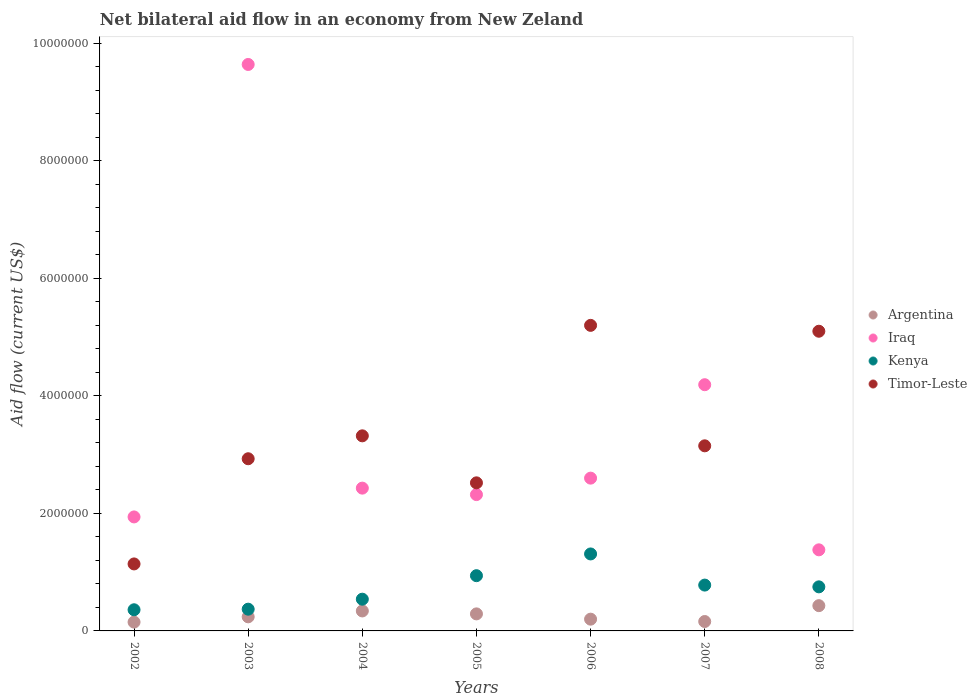What is the net bilateral aid flow in Timor-Leste in 2007?
Provide a succinct answer. 3.15e+06. Across all years, what is the minimum net bilateral aid flow in Iraq?
Offer a very short reply. 1.38e+06. In which year was the net bilateral aid flow in Kenya maximum?
Your answer should be compact. 2006. What is the total net bilateral aid flow in Iraq in the graph?
Provide a succinct answer. 2.45e+07. What is the average net bilateral aid flow in Kenya per year?
Your answer should be very brief. 7.21e+05. In the year 2004, what is the difference between the net bilateral aid flow in Iraq and net bilateral aid flow in Kenya?
Your answer should be very brief. 1.89e+06. In how many years, is the net bilateral aid flow in Argentina greater than 9600000 US$?
Offer a terse response. 0. What is the ratio of the net bilateral aid flow in Timor-Leste in 2004 to that in 2006?
Your answer should be very brief. 0.64. Is the net bilateral aid flow in Kenya in 2003 less than that in 2004?
Give a very brief answer. Yes. Is the difference between the net bilateral aid flow in Iraq in 2002 and 2008 greater than the difference between the net bilateral aid flow in Kenya in 2002 and 2008?
Your response must be concise. Yes. What is the difference between the highest and the second highest net bilateral aid flow in Timor-Leste?
Provide a short and direct response. 1.00e+05. In how many years, is the net bilateral aid flow in Timor-Leste greater than the average net bilateral aid flow in Timor-Leste taken over all years?
Your response must be concise. 2. Is the sum of the net bilateral aid flow in Iraq in 2003 and 2004 greater than the maximum net bilateral aid flow in Timor-Leste across all years?
Offer a very short reply. Yes. Is it the case that in every year, the sum of the net bilateral aid flow in Timor-Leste and net bilateral aid flow in Iraq  is greater than the sum of net bilateral aid flow in Kenya and net bilateral aid flow in Argentina?
Make the answer very short. Yes. Is it the case that in every year, the sum of the net bilateral aid flow in Iraq and net bilateral aid flow in Kenya  is greater than the net bilateral aid flow in Timor-Leste?
Make the answer very short. No. Does the net bilateral aid flow in Argentina monotonically increase over the years?
Your answer should be very brief. No. How many years are there in the graph?
Make the answer very short. 7. What is the difference between two consecutive major ticks on the Y-axis?
Your answer should be compact. 2.00e+06. Does the graph contain any zero values?
Your response must be concise. No. How are the legend labels stacked?
Ensure brevity in your answer.  Vertical. What is the title of the graph?
Ensure brevity in your answer.  Net bilateral aid flow in an economy from New Zeland. Does "Suriname" appear as one of the legend labels in the graph?
Provide a short and direct response. No. What is the Aid flow (current US$) of Argentina in 2002?
Provide a short and direct response. 1.50e+05. What is the Aid flow (current US$) in Iraq in 2002?
Make the answer very short. 1.94e+06. What is the Aid flow (current US$) in Timor-Leste in 2002?
Your response must be concise. 1.14e+06. What is the Aid flow (current US$) in Iraq in 2003?
Offer a very short reply. 9.64e+06. What is the Aid flow (current US$) in Timor-Leste in 2003?
Offer a terse response. 2.93e+06. What is the Aid flow (current US$) of Iraq in 2004?
Provide a succinct answer. 2.43e+06. What is the Aid flow (current US$) of Kenya in 2004?
Offer a very short reply. 5.40e+05. What is the Aid flow (current US$) of Timor-Leste in 2004?
Make the answer very short. 3.32e+06. What is the Aid flow (current US$) of Iraq in 2005?
Offer a very short reply. 2.32e+06. What is the Aid flow (current US$) of Kenya in 2005?
Provide a succinct answer. 9.40e+05. What is the Aid flow (current US$) in Timor-Leste in 2005?
Make the answer very short. 2.52e+06. What is the Aid flow (current US$) of Iraq in 2006?
Provide a short and direct response. 2.60e+06. What is the Aid flow (current US$) in Kenya in 2006?
Offer a very short reply. 1.31e+06. What is the Aid flow (current US$) in Timor-Leste in 2006?
Ensure brevity in your answer.  5.20e+06. What is the Aid flow (current US$) in Argentina in 2007?
Keep it short and to the point. 1.60e+05. What is the Aid flow (current US$) of Iraq in 2007?
Your answer should be very brief. 4.19e+06. What is the Aid flow (current US$) in Kenya in 2007?
Provide a short and direct response. 7.80e+05. What is the Aid flow (current US$) of Timor-Leste in 2007?
Offer a very short reply. 3.15e+06. What is the Aid flow (current US$) in Argentina in 2008?
Your answer should be compact. 4.30e+05. What is the Aid flow (current US$) of Iraq in 2008?
Make the answer very short. 1.38e+06. What is the Aid flow (current US$) of Kenya in 2008?
Make the answer very short. 7.50e+05. What is the Aid flow (current US$) in Timor-Leste in 2008?
Give a very brief answer. 5.10e+06. Across all years, what is the maximum Aid flow (current US$) of Argentina?
Offer a terse response. 4.30e+05. Across all years, what is the maximum Aid flow (current US$) in Iraq?
Offer a very short reply. 9.64e+06. Across all years, what is the maximum Aid flow (current US$) in Kenya?
Provide a succinct answer. 1.31e+06. Across all years, what is the maximum Aid flow (current US$) in Timor-Leste?
Offer a terse response. 5.20e+06. Across all years, what is the minimum Aid flow (current US$) in Iraq?
Give a very brief answer. 1.38e+06. Across all years, what is the minimum Aid flow (current US$) of Kenya?
Offer a terse response. 3.60e+05. Across all years, what is the minimum Aid flow (current US$) of Timor-Leste?
Your answer should be compact. 1.14e+06. What is the total Aid flow (current US$) in Argentina in the graph?
Provide a short and direct response. 1.81e+06. What is the total Aid flow (current US$) of Iraq in the graph?
Ensure brevity in your answer.  2.45e+07. What is the total Aid flow (current US$) in Kenya in the graph?
Make the answer very short. 5.05e+06. What is the total Aid flow (current US$) of Timor-Leste in the graph?
Your response must be concise. 2.34e+07. What is the difference between the Aid flow (current US$) of Iraq in 2002 and that in 2003?
Provide a short and direct response. -7.70e+06. What is the difference between the Aid flow (current US$) of Kenya in 2002 and that in 2003?
Give a very brief answer. -10000. What is the difference between the Aid flow (current US$) in Timor-Leste in 2002 and that in 2003?
Offer a very short reply. -1.79e+06. What is the difference between the Aid flow (current US$) of Argentina in 2002 and that in 2004?
Your answer should be compact. -1.90e+05. What is the difference between the Aid flow (current US$) in Iraq in 2002 and that in 2004?
Offer a terse response. -4.90e+05. What is the difference between the Aid flow (current US$) of Kenya in 2002 and that in 2004?
Make the answer very short. -1.80e+05. What is the difference between the Aid flow (current US$) of Timor-Leste in 2002 and that in 2004?
Your answer should be very brief. -2.18e+06. What is the difference between the Aid flow (current US$) in Iraq in 2002 and that in 2005?
Give a very brief answer. -3.80e+05. What is the difference between the Aid flow (current US$) of Kenya in 2002 and that in 2005?
Offer a terse response. -5.80e+05. What is the difference between the Aid flow (current US$) of Timor-Leste in 2002 and that in 2005?
Offer a terse response. -1.38e+06. What is the difference between the Aid flow (current US$) in Iraq in 2002 and that in 2006?
Provide a short and direct response. -6.60e+05. What is the difference between the Aid flow (current US$) of Kenya in 2002 and that in 2006?
Keep it short and to the point. -9.50e+05. What is the difference between the Aid flow (current US$) in Timor-Leste in 2002 and that in 2006?
Your answer should be compact. -4.06e+06. What is the difference between the Aid flow (current US$) in Argentina in 2002 and that in 2007?
Your answer should be compact. -10000. What is the difference between the Aid flow (current US$) of Iraq in 2002 and that in 2007?
Give a very brief answer. -2.25e+06. What is the difference between the Aid flow (current US$) of Kenya in 2002 and that in 2007?
Your answer should be compact. -4.20e+05. What is the difference between the Aid flow (current US$) of Timor-Leste in 2002 and that in 2007?
Offer a very short reply. -2.01e+06. What is the difference between the Aid flow (current US$) of Argentina in 2002 and that in 2008?
Provide a short and direct response. -2.80e+05. What is the difference between the Aid flow (current US$) in Iraq in 2002 and that in 2008?
Make the answer very short. 5.60e+05. What is the difference between the Aid flow (current US$) in Kenya in 2002 and that in 2008?
Your response must be concise. -3.90e+05. What is the difference between the Aid flow (current US$) of Timor-Leste in 2002 and that in 2008?
Keep it short and to the point. -3.96e+06. What is the difference between the Aid flow (current US$) in Iraq in 2003 and that in 2004?
Ensure brevity in your answer.  7.21e+06. What is the difference between the Aid flow (current US$) in Timor-Leste in 2003 and that in 2004?
Keep it short and to the point. -3.90e+05. What is the difference between the Aid flow (current US$) of Argentina in 2003 and that in 2005?
Your answer should be compact. -5.00e+04. What is the difference between the Aid flow (current US$) of Iraq in 2003 and that in 2005?
Your answer should be compact. 7.32e+06. What is the difference between the Aid flow (current US$) in Kenya in 2003 and that in 2005?
Your answer should be compact. -5.70e+05. What is the difference between the Aid flow (current US$) of Iraq in 2003 and that in 2006?
Offer a very short reply. 7.04e+06. What is the difference between the Aid flow (current US$) in Kenya in 2003 and that in 2006?
Offer a terse response. -9.40e+05. What is the difference between the Aid flow (current US$) in Timor-Leste in 2003 and that in 2006?
Ensure brevity in your answer.  -2.27e+06. What is the difference between the Aid flow (current US$) of Iraq in 2003 and that in 2007?
Keep it short and to the point. 5.45e+06. What is the difference between the Aid flow (current US$) of Kenya in 2003 and that in 2007?
Offer a very short reply. -4.10e+05. What is the difference between the Aid flow (current US$) of Argentina in 2003 and that in 2008?
Make the answer very short. -1.90e+05. What is the difference between the Aid flow (current US$) in Iraq in 2003 and that in 2008?
Give a very brief answer. 8.26e+06. What is the difference between the Aid flow (current US$) of Kenya in 2003 and that in 2008?
Your response must be concise. -3.80e+05. What is the difference between the Aid flow (current US$) of Timor-Leste in 2003 and that in 2008?
Provide a succinct answer. -2.17e+06. What is the difference between the Aid flow (current US$) in Kenya in 2004 and that in 2005?
Offer a very short reply. -4.00e+05. What is the difference between the Aid flow (current US$) of Argentina in 2004 and that in 2006?
Ensure brevity in your answer.  1.40e+05. What is the difference between the Aid flow (current US$) in Kenya in 2004 and that in 2006?
Your answer should be very brief. -7.70e+05. What is the difference between the Aid flow (current US$) in Timor-Leste in 2004 and that in 2006?
Keep it short and to the point. -1.88e+06. What is the difference between the Aid flow (current US$) of Iraq in 2004 and that in 2007?
Your answer should be compact. -1.76e+06. What is the difference between the Aid flow (current US$) in Timor-Leste in 2004 and that in 2007?
Offer a terse response. 1.70e+05. What is the difference between the Aid flow (current US$) of Argentina in 2004 and that in 2008?
Your answer should be very brief. -9.00e+04. What is the difference between the Aid flow (current US$) of Iraq in 2004 and that in 2008?
Your response must be concise. 1.05e+06. What is the difference between the Aid flow (current US$) of Kenya in 2004 and that in 2008?
Your answer should be compact. -2.10e+05. What is the difference between the Aid flow (current US$) in Timor-Leste in 2004 and that in 2008?
Your answer should be very brief. -1.78e+06. What is the difference between the Aid flow (current US$) in Argentina in 2005 and that in 2006?
Make the answer very short. 9.00e+04. What is the difference between the Aid flow (current US$) of Iraq in 2005 and that in 2006?
Your answer should be compact. -2.80e+05. What is the difference between the Aid flow (current US$) of Kenya in 2005 and that in 2006?
Offer a terse response. -3.70e+05. What is the difference between the Aid flow (current US$) of Timor-Leste in 2005 and that in 2006?
Give a very brief answer. -2.68e+06. What is the difference between the Aid flow (current US$) in Argentina in 2005 and that in 2007?
Your response must be concise. 1.30e+05. What is the difference between the Aid flow (current US$) in Iraq in 2005 and that in 2007?
Provide a short and direct response. -1.87e+06. What is the difference between the Aid flow (current US$) in Timor-Leste in 2005 and that in 2007?
Keep it short and to the point. -6.30e+05. What is the difference between the Aid flow (current US$) of Argentina in 2005 and that in 2008?
Your response must be concise. -1.40e+05. What is the difference between the Aid flow (current US$) in Iraq in 2005 and that in 2008?
Your response must be concise. 9.40e+05. What is the difference between the Aid flow (current US$) in Timor-Leste in 2005 and that in 2008?
Ensure brevity in your answer.  -2.58e+06. What is the difference between the Aid flow (current US$) of Iraq in 2006 and that in 2007?
Give a very brief answer. -1.59e+06. What is the difference between the Aid flow (current US$) of Kenya in 2006 and that in 2007?
Your answer should be very brief. 5.30e+05. What is the difference between the Aid flow (current US$) of Timor-Leste in 2006 and that in 2007?
Make the answer very short. 2.05e+06. What is the difference between the Aid flow (current US$) in Iraq in 2006 and that in 2008?
Provide a short and direct response. 1.22e+06. What is the difference between the Aid flow (current US$) in Kenya in 2006 and that in 2008?
Your answer should be compact. 5.60e+05. What is the difference between the Aid flow (current US$) in Timor-Leste in 2006 and that in 2008?
Ensure brevity in your answer.  1.00e+05. What is the difference between the Aid flow (current US$) in Iraq in 2007 and that in 2008?
Make the answer very short. 2.81e+06. What is the difference between the Aid flow (current US$) in Timor-Leste in 2007 and that in 2008?
Your answer should be compact. -1.95e+06. What is the difference between the Aid flow (current US$) of Argentina in 2002 and the Aid flow (current US$) of Iraq in 2003?
Your answer should be compact. -9.49e+06. What is the difference between the Aid flow (current US$) of Argentina in 2002 and the Aid flow (current US$) of Kenya in 2003?
Your answer should be very brief. -2.20e+05. What is the difference between the Aid flow (current US$) in Argentina in 2002 and the Aid flow (current US$) in Timor-Leste in 2003?
Offer a terse response. -2.78e+06. What is the difference between the Aid flow (current US$) of Iraq in 2002 and the Aid flow (current US$) of Kenya in 2003?
Make the answer very short. 1.57e+06. What is the difference between the Aid flow (current US$) of Iraq in 2002 and the Aid flow (current US$) of Timor-Leste in 2003?
Your answer should be compact. -9.90e+05. What is the difference between the Aid flow (current US$) of Kenya in 2002 and the Aid flow (current US$) of Timor-Leste in 2003?
Your answer should be very brief. -2.57e+06. What is the difference between the Aid flow (current US$) of Argentina in 2002 and the Aid flow (current US$) of Iraq in 2004?
Your answer should be compact. -2.28e+06. What is the difference between the Aid flow (current US$) in Argentina in 2002 and the Aid flow (current US$) in Kenya in 2004?
Offer a terse response. -3.90e+05. What is the difference between the Aid flow (current US$) of Argentina in 2002 and the Aid flow (current US$) of Timor-Leste in 2004?
Provide a succinct answer. -3.17e+06. What is the difference between the Aid flow (current US$) of Iraq in 2002 and the Aid flow (current US$) of Kenya in 2004?
Your answer should be very brief. 1.40e+06. What is the difference between the Aid flow (current US$) in Iraq in 2002 and the Aid flow (current US$) in Timor-Leste in 2004?
Your response must be concise. -1.38e+06. What is the difference between the Aid flow (current US$) of Kenya in 2002 and the Aid flow (current US$) of Timor-Leste in 2004?
Ensure brevity in your answer.  -2.96e+06. What is the difference between the Aid flow (current US$) in Argentina in 2002 and the Aid flow (current US$) in Iraq in 2005?
Make the answer very short. -2.17e+06. What is the difference between the Aid flow (current US$) of Argentina in 2002 and the Aid flow (current US$) of Kenya in 2005?
Your response must be concise. -7.90e+05. What is the difference between the Aid flow (current US$) of Argentina in 2002 and the Aid flow (current US$) of Timor-Leste in 2005?
Offer a terse response. -2.37e+06. What is the difference between the Aid flow (current US$) of Iraq in 2002 and the Aid flow (current US$) of Kenya in 2005?
Give a very brief answer. 1.00e+06. What is the difference between the Aid flow (current US$) in Iraq in 2002 and the Aid flow (current US$) in Timor-Leste in 2005?
Your response must be concise. -5.80e+05. What is the difference between the Aid flow (current US$) in Kenya in 2002 and the Aid flow (current US$) in Timor-Leste in 2005?
Provide a short and direct response. -2.16e+06. What is the difference between the Aid flow (current US$) in Argentina in 2002 and the Aid flow (current US$) in Iraq in 2006?
Provide a succinct answer. -2.45e+06. What is the difference between the Aid flow (current US$) in Argentina in 2002 and the Aid flow (current US$) in Kenya in 2006?
Ensure brevity in your answer.  -1.16e+06. What is the difference between the Aid flow (current US$) in Argentina in 2002 and the Aid flow (current US$) in Timor-Leste in 2006?
Offer a very short reply. -5.05e+06. What is the difference between the Aid flow (current US$) in Iraq in 2002 and the Aid flow (current US$) in Kenya in 2006?
Offer a very short reply. 6.30e+05. What is the difference between the Aid flow (current US$) of Iraq in 2002 and the Aid flow (current US$) of Timor-Leste in 2006?
Your answer should be compact. -3.26e+06. What is the difference between the Aid flow (current US$) in Kenya in 2002 and the Aid flow (current US$) in Timor-Leste in 2006?
Your answer should be very brief. -4.84e+06. What is the difference between the Aid flow (current US$) in Argentina in 2002 and the Aid flow (current US$) in Iraq in 2007?
Keep it short and to the point. -4.04e+06. What is the difference between the Aid flow (current US$) in Argentina in 2002 and the Aid flow (current US$) in Kenya in 2007?
Give a very brief answer. -6.30e+05. What is the difference between the Aid flow (current US$) in Iraq in 2002 and the Aid flow (current US$) in Kenya in 2007?
Provide a succinct answer. 1.16e+06. What is the difference between the Aid flow (current US$) of Iraq in 2002 and the Aid flow (current US$) of Timor-Leste in 2007?
Your answer should be compact. -1.21e+06. What is the difference between the Aid flow (current US$) of Kenya in 2002 and the Aid flow (current US$) of Timor-Leste in 2007?
Provide a short and direct response. -2.79e+06. What is the difference between the Aid flow (current US$) in Argentina in 2002 and the Aid flow (current US$) in Iraq in 2008?
Keep it short and to the point. -1.23e+06. What is the difference between the Aid flow (current US$) of Argentina in 2002 and the Aid flow (current US$) of Kenya in 2008?
Keep it short and to the point. -6.00e+05. What is the difference between the Aid flow (current US$) in Argentina in 2002 and the Aid flow (current US$) in Timor-Leste in 2008?
Your response must be concise. -4.95e+06. What is the difference between the Aid flow (current US$) of Iraq in 2002 and the Aid flow (current US$) of Kenya in 2008?
Your answer should be very brief. 1.19e+06. What is the difference between the Aid flow (current US$) of Iraq in 2002 and the Aid flow (current US$) of Timor-Leste in 2008?
Your response must be concise. -3.16e+06. What is the difference between the Aid flow (current US$) in Kenya in 2002 and the Aid flow (current US$) in Timor-Leste in 2008?
Provide a short and direct response. -4.74e+06. What is the difference between the Aid flow (current US$) in Argentina in 2003 and the Aid flow (current US$) in Iraq in 2004?
Offer a terse response. -2.19e+06. What is the difference between the Aid flow (current US$) of Argentina in 2003 and the Aid flow (current US$) of Timor-Leste in 2004?
Your response must be concise. -3.08e+06. What is the difference between the Aid flow (current US$) in Iraq in 2003 and the Aid flow (current US$) in Kenya in 2004?
Provide a short and direct response. 9.10e+06. What is the difference between the Aid flow (current US$) of Iraq in 2003 and the Aid flow (current US$) of Timor-Leste in 2004?
Your answer should be compact. 6.32e+06. What is the difference between the Aid flow (current US$) of Kenya in 2003 and the Aid flow (current US$) of Timor-Leste in 2004?
Offer a very short reply. -2.95e+06. What is the difference between the Aid flow (current US$) of Argentina in 2003 and the Aid flow (current US$) of Iraq in 2005?
Your response must be concise. -2.08e+06. What is the difference between the Aid flow (current US$) of Argentina in 2003 and the Aid flow (current US$) of Kenya in 2005?
Make the answer very short. -7.00e+05. What is the difference between the Aid flow (current US$) of Argentina in 2003 and the Aid flow (current US$) of Timor-Leste in 2005?
Provide a succinct answer. -2.28e+06. What is the difference between the Aid flow (current US$) in Iraq in 2003 and the Aid flow (current US$) in Kenya in 2005?
Provide a short and direct response. 8.70e+06. What is the difference between the Aid flow (current US$) in Iraq in 2003 and the Aid flow (current US$) in Timor-Leste in 2005?
Offer a terse response. 7.12e+06. What is the difference between the Aid flow (current US$) of Kenya in 2003 and the Aid flow (current US$) of Timor-Leste in 2005?
Your response must be concise. -2.15e+06. What is the difference between the Aid flow (current US$) in Argentina in 2003 and the Aid flow (current US$) in Iraq in 2006?
Give a very brief answer. -2.36e+06. What is the difference between the Aid flow (current US$) in Argentina in 2003 and the Aid flow (current US$) in Kenya in 2006?
Provide a short and direct response. -1.07e+06. What is the difference between the Aid flow (current US$) in Argentina in 2003 and the Aid flow (current US$) in Timor-Leste in 2006?
Provide a short and direct response. -4.96e+06. What is the difference between the Aid flow (current US$) of Iraq in 2003 and the Aid flow (current US$) of Kenya in 2006?
Ensure brevity in your answer.  8.33e+06. What is the difference between the Aid flow (current US$) in Iraq in 2003 and the Aid flow (current US$) in Timor-Leste in 2006?
Offer a very short reply. 4.44e+06. What is the difference between the Aid flow (current US$) of Kenya in 2003 and the Aid flow (current US$) of Timor-Leste in 2006?
Keep it short and to the point. -4.83e+06. What is the difference between the Aid flow (current US$) of Argentina in 2003 and the Aid flow (current US$) of Iraq in 2007?
Make the answer very short. -3.95e+06. What is the difference between the Aid flow (current US$) in Argentina in 2003 and the Aid flow (current US$) in Kenya in 2007?
Your answer should be compact. -5.40e+05. What is the difference between the Aid flow (current US$) of Argentina in 2003 and the Aid flow (current US$) of Timor-Leste in 2007?
Offer a very short reply. -2.91e+06. What is the difference between the Aid flow (current US$) of Iraq in 2003 and the Aid flow (current US$) of Kenya in 2007?
Provide a succinct answer. 8.86e+06. What is the difference between the Aid flow (current US$) of Iraq in 2003 and the Aid flow (current US$) of Timor-Leste in 2007?
Your answer should be very brief. 6.49e+06. What is the difference between the Aid flow (current US$) of Kenya in 2003 and the Aid flow (current US$) of Timor-Leste in 2007?
Offer a terse response. -2.78e+06. What is the difference between the Aid flow (current US$) of Argentina in 2003 and the Aid flow (current US$) of Iraq in 2008?
Give a very brief answer. -1.14e+06. What is the difference between the Aid flow (current US$) in Argentina in 2003 and the Aid flow (current US$) in Kenya in 2008?
Your answer should be very brief. -5.10e+05. What is the difference between the Aid flow (current US$) in Argentina in 2003 and the Aid flow (current US$) in Timor-Leste in 2008?
Make the answer very short. -4.86e+06. What is the difference between the Aid flow (current US$) in Iraq in 2003 and the Aid flow (current US$) in Kenya in 2008?
Provide a short and direct response. 8.89e+06. What is the difference between the Aid flow (current US$) of Iraq in 2003 and the Aid flow (current US$) of Timor-Leste in 2008?
Offer a terse response. 4.54e+06. What is the difference between the Aid flow (current US$) of Kenya in 2003 and the Aid flow (current US$) of Timor-Leste in 2008?
Provide a short and direct response. -4.73e+06. What is the difference between the Aid flow (current US$) of Argentina in 2004 and the Aid flow (current US$) of Iraq in 2005?
Provide a succinct answer. -1.98e+06. What is the difference between the Aid flow (current US$) in Argentina in 2004 and the Aid flow (current US$) in Kenya in 2005?
Give a very brief answer. -6.00e+05. What is the difference between the Aid flow (current US$) of Argentina in 2004 and the Aid flow (current US$) of Timor-Leste in 2005?
Offer a very short reply. -2.18e+06. What is the difference between the Aid flow (current US$) in Iraq in 2004 and the Aid flow (current US$) in Kenya in 2005?
Provide a short and direct response. 1.49e+06. What is the difference between the Aid flow (current US$) in Iraq in 2004 and the Aid flow (current US$) in Timor-Leste in 2005?
Your response must be concise. -9.00e+04. What is the difference between the Aid flow (current US$) in Kenya in 2004 and the Aid flow (current US$) in Timor-Leste in 2005?
Ensure brevity in your answer.  -1.98e+06. What is the difference between the Aid flow (current US$) in Argentina in 2004 and the Aid flow (current US$) in Iraq in 2006?
Ensure brevity in your answer.  -2.26e+06. What is the difference between the Aid flow (current US$) in Argentina in 2004 and the Aid flow (current US$) in Kenya in 2006?
Your response must be concise. -9.70e+05. What is the difference between the Aid flow (current US$) of Argentina in 2004 and the Aid flow (current US$) of Timor-Leste in 2006?
Your response must be concise. -4.86e+06. What is the difference between the Aid flow (current US$) of Iraq in 2004 and the Aid flow (current US$) of Kenya in 2006?
Your answer should be very brief. 1.12e+06. What is the difference between the Aid flow (current US$) in Iraq in 2004 and the Aid flow (current US$) in Timor-Leste in 2006?
Keep it short and to the point. -2.77e+06. What is the difference between the Aid flow (current US$) of Kenya in 2004 and the Aid flow (current US$) of Timor-Leste in 2006?
Make the answer very short. -4.66e+06. What is the difference between the Aid flow (current US$) in Argentina in 2004 and the Aid flow (current US$) in Iraq in 2007?
Ensure brevity in your answer.  -3.85e+06. What is the difference between the Aid flow (current US$) in Argentina in 2004 and the Aid flow (current US$) in Kenya in 2007?
Make the answer very short. -4.40e+05. What is the difference between the Aid flow (current US$) in Argentina in 2004 and the Aid flow (current US$) in Timor-Leste in 2007?
Offer a very short reply. -2.81e+06. What is the difference between the Aid flow (current US$) in Iraq in 2004 and the Aid flow (current US$) in Kenya in 2007?
Your response must be concise. 1.65e+06. What is the difference between the Aid flow (current US$) in Iraq in 2004 and the Aid flow (current US$) in Timor-Leste in 2007?
Make the answer very short. -7.20e+05. What is the difference between the Aid flow (current US$) in Kenya in 2004 and the Aid flow (current US$) in Timor-Leste in 2007?
Your response must be concise. -2.61e+06. What is the difference between the Aid flow (current US$) of Argentina in 2004 and the Aid flow (current US$) of Iraq in 2008?
Give a very brief answer. -1.04e+06. What is the difference between the Aid flow (current US$) of Argentina in 2004 and the Aid flow (current US$) of Kenya in 2008?
Your answer should be compact. -4.10e+05. What is the difference between the Aid flow (current US$) in Argentina in 2004 and the Aid flow (current US$) in Timor-Leste in 2008?
Your answer should be very brief. -4.76e+06. What is the difference between the Aid flow (current US$) of Iraq in 2004 and the Aid flow (current US$) of Kenya in 2008?
Offer a terse response. 1.68e+06. What is the difference between the Aid flow (current US$) of Iraq in 2004 and the Aid flow (current US$) of Timor-Leste in 2008?
Your answer should be very brief. -2.67e+06. What is the difference between the Aid flow (current US$) in Kenya in 2004 and the Aid flow (current US$) in Timor-Leste in 2008?
Your answer should be very brief. -4.56e+06. What is the difference between the Aid flow (current US$) of Argentina in 2005 and the Aid flow (current US$) of Iraq in 2006?
Keep it short and to the point. -2.31e+06. What is the difference between the Aid flow (current US$) of Argentina in 2005 and the Aid flow (current US$) of Kenya in 2006?
Offer a very short reply. -1.02e+06. What is the difference between the Aid flow (current US$) of Argentina in 2005 and the Aid flow (current US$) of Timor-Leste in 2006?
Offer a terse response. -4.91e+06. What is the difference between the Aid flow (current US$) in Iraq in 2005 and the Aid flow (current US$) in Kenya in 2006?
Make the answer very short. 1.01e+06. What is the difference between the Aid flow (current US$) of Iraq in 2005 and the Aid flow (current US$) of Timor-Leste in 2006?
Provide a succinct answer. -2.88e+06. What is the difference between the Aid flow (current US$) in Kenya in 2005 and the Aid flow (current US$) in Timor-Leste in 2006?
Provide a short and direct response. -4.26e+06. What is the difference between the Aid flow (current US$) in Argentina in 2005 and the Aid flow (current US$) in Iraq in 2007?
Give a very brief answer. -3.90e+06. What is the difference between the Aid flow (current US$) of Argentina in 2005 and the Aid flow (current US$) of Kenya in 2007?
Ensure brevity in your answer.  -4.90e+05. What is the difference between the Aid flow (current US$) in Argentina in 2005 and the Aid flow (current US$) in Timor-Leste in 2007?
Offer a very short reply. -2.86e+06. What is the difference between the Aid flow (current US$) in Iraq in 2005 and the Aid flow (current US$) in Kenya in 2007?
Give a very brief answer. 1.54e+06. What is the difference between the Aid flow (current US$) in Iraq in 2005 and the Aid flow (current US$) in Timor-Leste in 2007?
Provide a short and direct response. -8.30e+05. What is the difference between the Aid flow (current US$) in Kenya in 2005 and the Aid flow (current US$) in Timor-Leste in 2007?
Provide a short and direct response. -2.21e+06. What is the difference between the Aid flow (current US$) of Argentina in 2005 and the Aid flow (current US$) of Iraq in 2008?
Offer a very short reply. -1.09e+06. What is the difference between the Aid flow (current US$) of Argentina in 2005 and the Aid flow (current US$) of Kenya in 2008?
Your answer should be very brief. -4.60e+05. What is the difference between the Aid flow (current US$) in Argentina in 2005 and the Aid flow (current US$) in Timor-Leste in 2008?
Offer a very short reply. -4.81e+06. What is the difference between the Aid flow (current US$) of Iraq in 2005 and the Aid flow (current US$) of Kenya in 2008?
Your answer should be compact. 1.57e+06. What is the difference between the Aid flow (current US$) of Iraq in 2005 and the Aid flow (current US$) of Timor-Leste in 2008?
Offer a very short reply. -2.78e+06. What is the difference between the Aid flow (current US$) in Kenya in 2005 and the Aid flow (current US$) in Timor-Leste in 2008?
Your response must be concise. -4.16e+06. What is the difference between the Aid flow (current US$) in Argentina in 2006 and the Aid flow (current US$) in Iraq in 2007?
Your response must be concise. -3.99e+06. What is the difference between the Aid flow (current US$) of Argentina in 2006 and the Aid flow (current US$) of Kenya in 2007?
Ensure brevity in your answer.  -5.80e+05. What is the difference between the Aid flow (current US$) of Argentina in 2006 and the Aid flow (current US$) of Timor-Leste in 2007?
Make the answer very short. -2.95e+06. What is the difference between the Aid flow (current US$) of Iraq in 2006 and the Aid flow (current US$) of Kenya in 2007?
Offer a very short reply. 1.82e+06. What is the difference between the Aid flow (current US$) of Iraq in 2006 and the Aid flow (current US$) of Timor-Leste in 2007?
Offer a very short reply. -5.50e+05. What is the difference between the Aid flow (current US$) of Kenya in 2006 and the Aid flow (current US$) of Timor-Leste in 2007?
Provide a succinct answer. -1.84e+06. What is the difference between the Aid flow (current US$) of Argentina in 2006 and the Aid flow (current US$) of Iraq in 2008?
Provide a short and direct response. -1.18e+06. What is the difference between the Aid flow (current US$) of Argentina in 2006 and the Aid flow (current US$) of Kenya in 2008?
Offer a very short reply. -5.50e+05. What is the difference between the Aid flow (current US$) of Argentina in 2006 and the Aid flow (current US$) of Timor-Leste in 2008?
Provide a succinct answer. -4.90e+06. What is the difference between the Aid flow (current US$) of Iraq in 2006 and the Aid flow (current US$) of Kenya in 2008?
Your response must be concise. 1.85e+06. What is the difference between the Aid flow (current US$) of Iraq in 2006 and the Aid flow (current US$) of Timor-Leste in 2008?
Provide a succinct answer. -2.50e+06. What is the difference between the Aid flow (current US$) of Kenya in 2006 and the Aid flow (current US$) of Timor-Leste in 2008?
Provide a short and direct response. -3.79e+06. What is the difference between the Aid flow (current US$) of Argentina in 2007 and the Aid flow (current US$) of Iraq in 2008?
Offer a very short reply. -1.22e+06. What is the difference between the Aid flow (current US$) of Argentina in 2007 and the Aid flow (current US$) of Kenya in 2008?
Give a very brief answer. -5.90e+05. What is the difference between the Aid flow (current US$) in Argentina in 2007 and the Aid flow (current US$) in Timor-Leste in 2008?
Your answer should be very brief. -4.94e+06. What is the difference between the Aid flow (current US$) in Iraq in 2007 and the Aid flow (current US$) in Kenya in 2008?
Your response must be concise. 3.44e+06. What is the difference between the Aid flow (current US$) of Iraq in 2007 and the Aid flow (current US$) of Timor-Leste in 2008?
Ensure brevity in your answer.  -9.10e+05. What is the difference between the Aid flow (current US$) in Kenya in 2007 and the Aid flow (current US$) in Timor-Leste in 2008?
Ensure brevity in your answer.  -4.32e+06. What is the average Aid flow (current US$) of Argentina per year?
Ensure brevity in your answer.  2.59e+05. What is the average Aid flow (current US$) of Iraq per year?
Make the answer very short. 3.50e+06. What is the average Aid flow (current US$) in Kenya per year?
Your answer should be compact. 7.21e+05. What is the average Aid flow (current US$) of Timor-Leste per year?
Keep it short and to the point. 3.34e+06. In the year 2002, what is the difference between the Aid flow (current US$) of Argentina and Aid flow (current US$) of Iraq?
Provide a short and direct response. -1.79e+06. In the year 2002, what is the difference between the Aid flow (current US$) of Argentina and Aid flow (current US$) of Kenya?
Provide a short and direct response. -2.10e+05. In the year 2002, what is the difference between the Aid flow (current US$) in Argentina and Aid flow (current US$) in Timor-Leste?
Your answer should be compact. -9.90e+05. In the year 2002, what is the difference between the Aid flow (current US$) of Iraq and Aid flow (current US$) of Kenya?
Make the answer very short. 1.58e+06. In the year 2002, what is the difference between the Aid flow (current US$) of Kenya and Aid flow (current US$) of Timor-Leste?
Your answer should be very brief. -7.80e+05. In the year 2003, what is the difference between the Aid flow (current US$) of Argentina and Aid flow (current US$) of Iraq?
Ensure brevity in your answer.  -9.40e+06. In the year 2003, what is the difference between the Aid flow (current US$) of Argentina and Aid flow (current US$) of Timor-Leste?
Your response must be concise. -2.69e+06. In the year 2003, what is the difference between the Aid flow (current US$) in Iraq and Aid flow (current US$) in Kenya?
Ensure brevity in your answer.  9.27e+06. In the year 2003, what is the difference between the Aid flow (current US$) of Iraq and Aid flow (current US$) of Timor-Leste?
Give a very brief answer. 6.71e+06. In the year 2003, what is the difference between the Aid flow (current US$) in Kenya and Aid flow (current US$) in Timor-Leste?
Provide a succinct answer. -2.56e+06. In the year 2004, what is the difference between the Aid flow (current US$) of Argentina and Aid flow (current US$) of Iraq?
Ensure brevity in your answer.  -2.09e+06. In the year 2004, what is the difference between the Aid flow (current US$) in Argentina and Aid flow (current US$) in Timor-Leste?
Provide a succinct answer. -2.98e+06. In the year 2004, what is the difference between the Aid flow (current US$) of Iraq and Aid flow (current US$) of Kenya?
Offer a very short reply. 1.89e+06. In the year 2004, what is the difference between the Aid flow (current US$) of Iraq and Aid flow (current US$) of Timor-Leste?
Offer a terse response. -8.90e+05. In the year 2004, what is the difference between the Aid flow (current US$) of Kenya and Aid flow (current US$) of Timor-Leste?
Offer a terse response. -2.78e+06. In the year 2005, what is the difference between the Aid flow (current US$) in Argentina and Aid flow (current US$) in Iraq?
Your answer should be very brief. -2.03e+06. In the year 2005, what is the difference between the Aid flow (current US$) of Argentina and Aid flow (current US$) of Kenya?
Offer a terse response. -6.50e+05. In the year 2005, what is the difference between the Aid flow (current US$) of Argentina and Aid flow (current US$) of Timor-Leste?
Your answer should be very brief. -2.23e+06. In the year 2005, what is the difference between the Aid flow (current US$) in Iraq and Aid flow (current US$) in Kenya?
Your response must be concise. 1.38e+06. In the year 2005, what is the difference between the Aid flow (current US$) in Kenya and Aid flow (current US$) in Timor-Leste?
Ensure brevity in your answer.  -1.58e+06. In the year 2006, what is the difference between the Aid flow (current US$) in Argentina and Aid flow (current US$) in Iraq?
Ensure brevity in your answer.  -2.40e+06. In the year 2006, what is the difference between the Aid flow (current US$) of Argentina and Aid flow (current US$) of Kenya?
Provide a short and direct response. -1.11e+06. In the year 2006, what is the difference between the Aid flow (current US$) of Argentina and Aid flow (current US$) of Timor-Leste?
Your response must be concise. -5.00e+06. In the year 2006, what is the difference between the Aid flow (current US$) of Iraq and Aid flow (current US$) of Kenya?
Provide a succinct answer. 1.29e+06. In the year 2006, what is the difference between the Aid flow (current US$) in Iraq and Aid flow (current US$) in Timor-Leste?
Give a very brief answer. -2.60e+06. In the year 2006, what is the difference between the Aid flow (current US$) in Kenya and Aid flow (current US$) in Timor-Leste?
Ensure brevity in your answer.  -3.89e+06. In the year 2007, what is the difference between the Aid flow (current US$) of Argentina and Aid flow (current US$) of Iraq?
Your response must be concise. -4.03e+06. In the year 2007, what is the difference between the Aid flow (current US$) of Argentina and Aid flow (current US$) of Kenya?
Ensure brevity in your answer.  -6.20e+05. In the year 2007, what is the difference between the Aid flow (current US$) of Argentina and Aid flow (current US$) of Timor-Leste?
Offer a terse response. -2.99e+06. In the year 2007, what is the difference between the Aid flow (current US$) in Iraq and Aid flow (current US$) in Kenya?
Your response must be concise. 3.41e+06. In the year 2007, what is the difference between the Aid flow (current US$) in Iraq and Aid flow (current US$) in Timor-Leste?
Your response must be concise. 1.04e+06. In the year 2007, what is the difference between the Aid flow (current US$) in Kenya and Aid flow (current US$) in Timor-Leste?
Provide a succinct answer. -2.37e+06. In the year 2008, what is the difference between the Aid flow (current US$) of Argentina and Aid flow (current US$) of Iraq?
Give a very brief answer. -9.50e+05. In the year 2008, what is the difference between the Aid flow (current US$) in Argentina and Aid flow (current US$) in Kenya?
Ensure brevity in your answer.  -3.20e+05. In the year 2008, what is the difference between the Aid flow (current US$) of Argentina and Aid flow (current US$) of Timor-Leste?
Give a very brief answer. -4.67e+06. In the year 2008, what is the difference between the Aid flow (current US$) of Iraq and Aid flow (current US$) of Kenya?
Keep it short and to the point. 6.30e+05. In the year 2008, what is the difference between the Aid flow (current US$) of Iraq and Aid flow (current US$) of Timor-Leste?
Your response must be concise. -3.72e+06. In the year 2008, what is the difference between the Aid flow (current US$) of Kenya and Aid flow (current US$) of Timor-Leste?
Your response must be concise. -4.35e+06. What is the ratio of the Aid flow (current US$) of Iraq in 2002 to that in 2003?
Provide a succinct answer. 0.2. What is the ratio of the Aid flow (current US$) in Timor-Leste in 2002 to that in 2003?
Keep it short and to the point. 0.39. What is the ratio of the Aid flow (current US$) in Argentina in 2002 to that in 2004?
Make the answer very short. 0.44. What is the ratio of the Aid flow (current US$) in Iraq in 2002 to that in 2004?
Provide a succinct answer. 0.8. What is the ratio of the Aid flow (current US$) in Timor-Leste in 2002 to that in 2004?
Provide a short and direct response. 0.34. What is the ratio of the Aid flow (current US$) in Argentina in 2002 to that in 2005?
Ensure brevity in your answer.  0.52. What is the ratio of the Aid flow (current US$) of Iraq in 2002 to that in 2005?
Provide a short and direct response. 0.84. What is the ratio of the Aid flow (current US$) in Kenya in 2002 to that in 2005?
Provide a succinct answer. 0.38. What is the ratio of the Aid flow (current US$) of Timor-Leste in 2002 to that in 2005?
Your answer should be compact. 0.45. What is the ratio of the Aid flow (current US$) in Argentina in 2002 to that in 2006?
Keep it short and to the point. 0.75. What is the ratio of the Aid flow (current US$) of Iraq in 2002 to that in 2006?
Provide a succinct answer. 0.75. What is the ratio of the Aid flow (current US$) in Kenya in 2002 to that in 2006?
Your answer should be very brief. 0.27. What is the ratio of the Aid flow (current US$) of Timor-Leste in 2002 to that in 2006?
Keep it short and to the point. 0.22. What is the ratio of the Aid flow (current US$) in Argentina in 2002 to that in 2007?
Offer a very short reply. 0.94. What is the ratio of the Aid flow (current US$) in Iraq in 2002 to that in 2007?
Your answer should be compact. 0.46. What is the ratio of the Aid flow (current US$) in Kenya in 2002 to that in 2007?
Keep it short and to the point. 0.46. What is the ratio of the Aid flow (current US$) in Timor-Leste in 2002 to that in 2007?
Keep it short and to the point. 0.36. What is the ratio of the Aid flow (current US$) in Argentina in 2002 to that in 2008?
Offer a terse response. 0.35. What is the ratio of the Aid flow (current US$) of Iraq in 2002 to that in 2008?
Ensure brevity in your answer.  1.41. What is the ratio of the Aid flow (current US$) of Kenya in 2002 to that in 2008?
Your response must be concise. 0.48. What is the ratio of the Aid flow (current US$) in Timor-Leste in 2002 to that in 2008?
Offer a very short reply. 0.22. What is the ratio of the Aid flow (current US$) of Argentina in 2003 to that in 2004?
Offer a terse response. 0.71. What is the ratio of the Aid flow (current US$) in Iraq in 2003 to that in 2004?
Keep it short and to the point. 3.97. What is the ratio of the Aid flow (current US$) of Kenya in 2003 to that in 2004?
Keep it short and to the point. 0.69. What is the ratio of the Aid flow (current US$) in Timor-Leste in 2003 to that in 2004?
Provide a succinct answer. 0.88. What is the ratio of the Aid flow (current US$) in Argentina in 2003 to that in 2005?
Ensure brevity in your answer.  0.83. What is the ratio of the Aid flow (current US$) of Iraq in 2003 to that in 2005?
Ensure brevity in your answer.  4.16. What is the ratio of the Aid flow (current US$) of Kenya in 2003 to that in 2005?
Offer a terse response. 0.39. What is the ratio of the Aid flow (current US$) of Timor-Leste in 2003 to that in 2005?
Make the answer very short. 1.16. What is the ratio of the Aid flow (current US$) of Iraq in 2003 to that in 2006?
Ensure brevity in your answer.  3.71. What is the ratio of the Aid flow (current US$) in Kenya in 2003 to that in 2006?
Your response must be concise. 0.28. What is the ratio of the Aid flow (current US$) in Timor-Leste in 2003 to that in 2006?
Offer a terse response. 0.56. What is the ratio of the Aid flow (current US$) in Iraq in 2003 to that in 2007?
Keep it short and to the point. 2.3. What is the ratio of the Aid flow (current US$) in Kenya in 2003 to that in 2007?
Offer a very short reply. 0.47. What is the ratio of the Aid flow (current US$) in Timor-Leste in 2003 to that in 2007?
Ensure brevity in your answer.  0.93. What is the ratio of the Aid flow (current US$) of Argentina in 2003 to that in 2008?
Keep it short and to the point. 0.56. What is the ratio of the Aid flow (current US$) in Iraq in 2003 to that in 2008?
Give a very brief answer. 6.99. What is the ratio of the Aid flow (current US$) of Kenya in 2003 to that in 2008?
Offer a terse response. 0.49. What is the ratio of the Aid flow (current US$) in Timor-Leste in 2003 to that in 2008?
Offer a very short reply. 0.57. What is the ratio of the Aid flow (current US$) in Argentina in 2004 to that in 2005?
Your response must be concise. 1.17. What is the ratio of the Aid flow (current US$) in Iraq in 2004 to that in 2005?
Make the answer very short. 1.05. What is the ratio of the Aid flow (current US$) in Kenya in 2004 to that in 2005?
Your answer should be very brief. 0.57. What is the ratio of the Aid flow (current US$) in Timor-Leste in 2004 to that in 2005?
Your answer should be very brief. 1.32. What is the ratio of the Aid flow (current US$) in Iraq in 2004 to that in 2006?
Provide a short and direct response. 0.93. What is the ratio of the Aid flow (current US$) in Kenya in 2004 to that in 2006?
Your answer should be compact. 0.41. What is the ratio of the Aid flow (current US$) of Timor-Leste in 2004 to that in 2006?
Keep it short and to the point. 0.64. What is the ratio of the Aid flow (current US$) of Argentina in 2004 to that in 2007?
Make the answer very short. 2.12. What is the ratio of the Aid flow (current US$) in Iraq in 2004 to that in 2007?
Provide a short and direct response. 0.58. What is the ratio of the Aid flow (current US$) in Kenya in 2004 to that in 2007?
Your response must be concise. 0.69. What is the ratio of the Aid flow (current US$) of Timor-Leste in 2004 to that in 2007?
Keep it short and to the point. 1.05. What is the ratio of the Aid flow (current US$) in Argentina in 2004 to that in 2008?
Your answer should be compact. 0.79. What is the ratio of the Aid flow (current US$) of Iraq in 2004 to that in 2008?
Offer a very short reply. 1.76. What is the ratio of the Aid flow (current US$) of Kenya in 2004 to that in 2008?
Offer a very short reply. 0.72. What is the ratio of the Aid flow (current US$) in Timor-Leste in 2004 to that in 2008?
Provide a succinct answer. 0.65. What is the ratio of the Aid flow (current US$) in Argentina in 2005 to that in 2006?
Offer a very short reply. 1.45. What is the ratio of the Aid flow (current US$) of Iraq in 2005 to that in 2006?
Your answer should be very brief. 0.89. What is the ratio of the Aid flow (current US$) of Kenya in 2005 to that in 2006?
Offer a terse response. 0.72. What is the ratio of the Aid flow (current US$) of Timor-Leste in 2005 to that in 2006?
Ensure brevity in your answer.  0.48. What is the ratio of the Aid flow (current US$) of Argentina in 2005 to that in 2007?
Your response must be concise. 1.81. What is the ratio of the Aid flow (current US$) of Iraq in 2005 to that in 2007?
Give a very brief answer. 0.55. What is the ratio of the Aid flow (current US$) of Kenya in 2005 to that in 2007?
Provide a succinct answer. 1.21. What is the ratio of the Aid flow (current US$) of Argentina in 2005 to that in 2008?
Keep it short and to the point. 0.67. What is the ratio of the Aid flow (current US$) of Iraq in 2005 to that in 2008?
Keep it short and to the point. 1.68. What is the ratio of the Aid flow (current US$) in Kenya in 2005 to that in 2008?
Offer a very short reply. 1.25. What is the ratio of the Aid flow (current US$) of Timor-Leste in 2005 to that in 2008?
Your answer should be very brief. 0.49. What is the ratio of the Aid flow (current US$) of Iraq in 2006 to that in 2007?
Keep it short and to the point. 0.62. What is the ratio of the Aid flow (current US$) of Kenya in 2006 to that in 2007?
Provide a short and direct response. 1.68. What is the ratio of the Aid flow (current US$) of Timor-Leste in 2006 to that in 2007?
Offer a very short reply. 1.65. What is the ratio of the Aid flow (current US$) of Argentina in 2006 to that in 2008?
Your response must be concise. 0.47. What is the ratio of the Aid flow (current US$) of Iraq in 2006 to that in 2008?
Give a very brief answer. 1.88. What is the ratio of the Aid flow (current US$) of Kenya in 2006 to that in 2008?
Your answer should be very brief. 1.75. What is the ratio of the Aid flow (current US$) in Timor-Leste in 2006 to that in 2008?
Offer a terse response. 1.02. What is the ratio of the Aid flow (current US$) in Argentina in 2007 to that in 2008?
Keep it short and to the point. 0.37. What is the ratio of the Aid flow (current US$) in Iraq in 2007 to that in 2008?
Keep it short and to the point. 3.04. What is the ratio of the Aid flow (current US$) of Kenya in 2007 to that in 2008?
Your answer should be compact. 1.04. What is the ratio of the Aid flow (current US$) in Timor-Leste in 2007 to that in 2008?
Make the answer very short. 0.62. What is the difference between the highest and the second highest Aid flow (current US$) of Iraq?
Keep it short and to the point. 5.45e+06. What is the difference between the highest and the second highest Aid flow (current US$) in Kenya?
Your answer should be compact. 3.70e+05. What is the difference between the highest and the second highest Aid flow (current US$) in Timor-Leste?
Ensure brevity in your answer.  1.00e+05. What is the difference between the highest and the lowest Aid flow (current US$) of Argentina?
Your answer should be compact. 2.80e+05. What is the difference between the highest and the lowest Aid flow (current US$) of Iraq?
Offer a terse response. 8.26e+06. What is the difference between the highest and the lowest Aid flow (current US$) of Kenya?
Ensure brevity in your answer.  9.50e+05. What is the difference between the highest and the lowest Aid flow (current US$) in Timor-Leste?
Your response must be concise. 4.06e+06. 